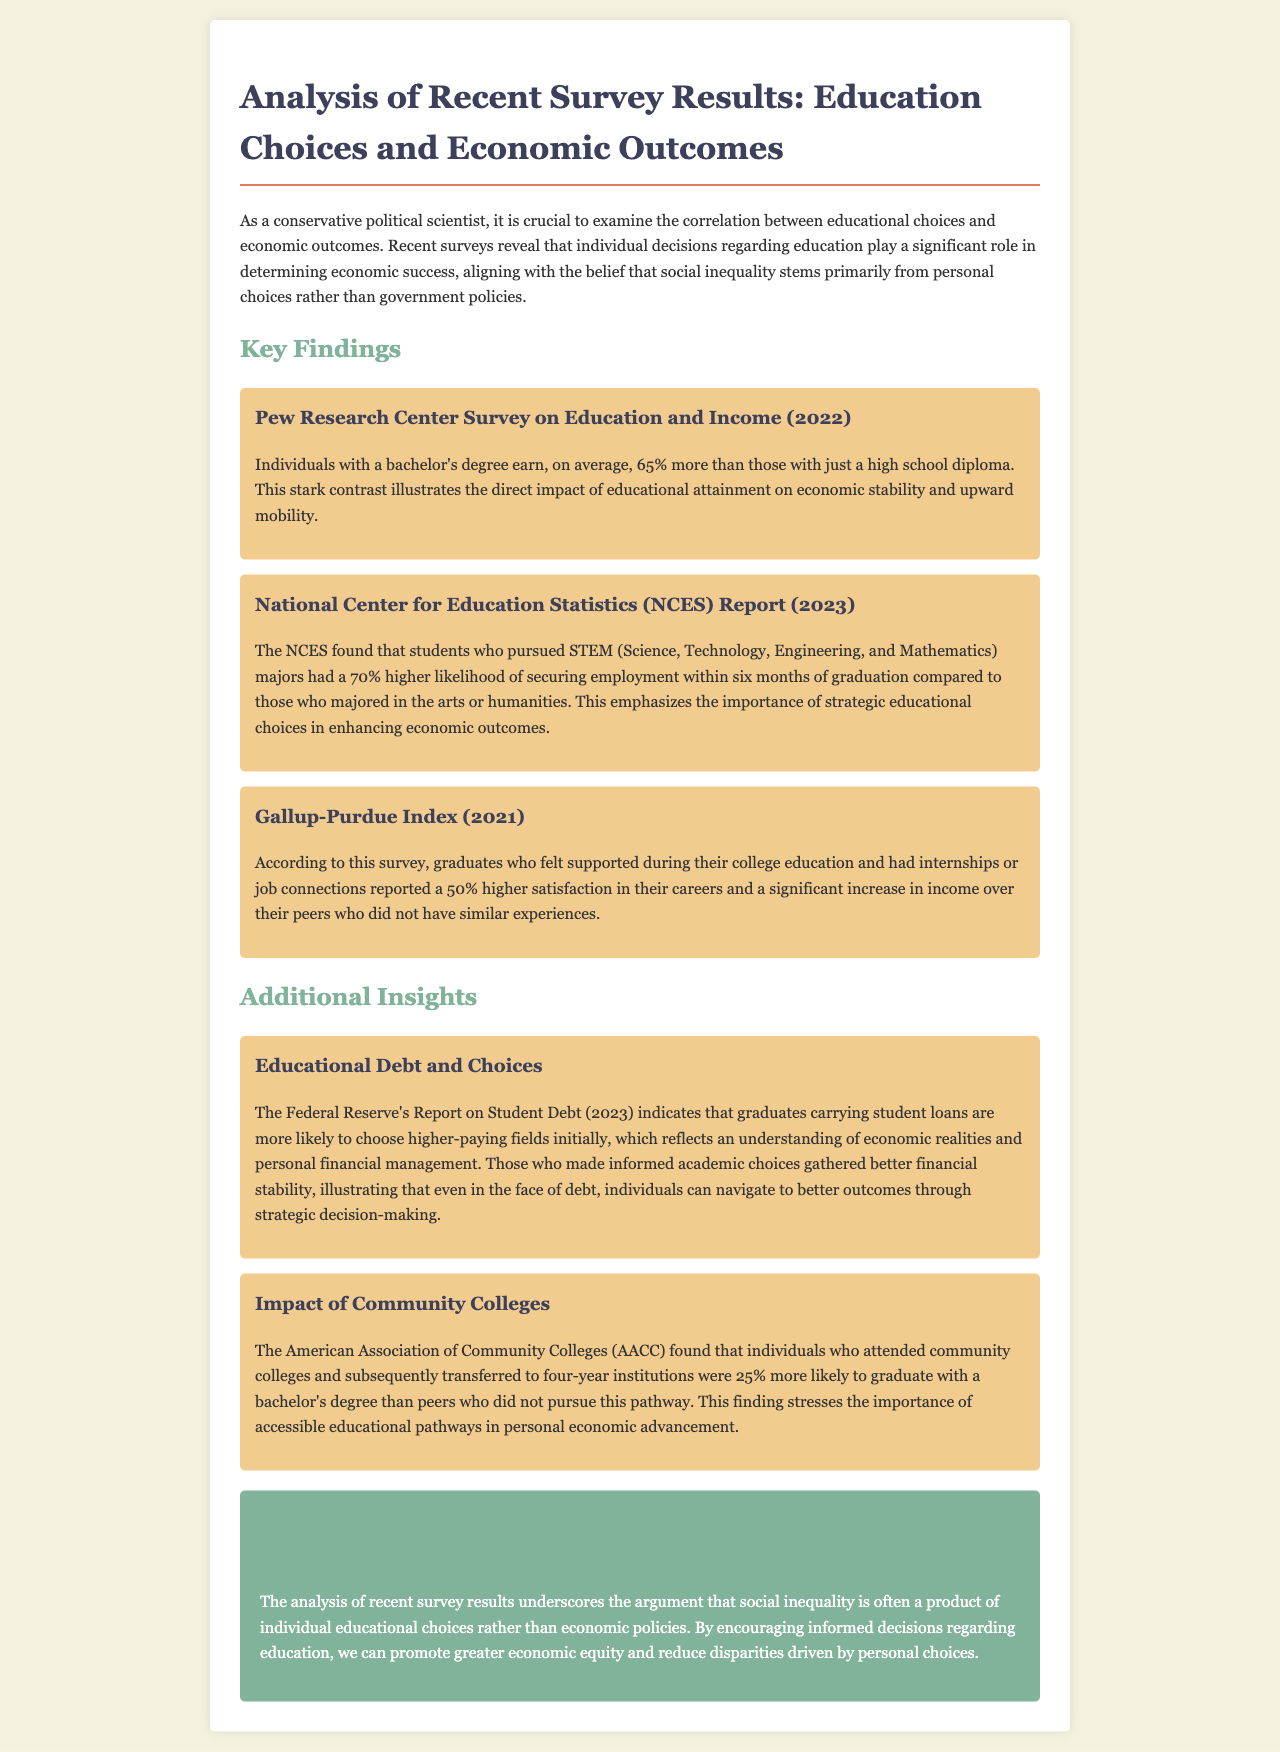What is the average income difference between individuals with a bachelor's degree and those with just a high school diploma? The document states that individuals with a bachelor's degree earn, on average, 65% more than those with just a high school diploma.
Answer: 65% What is the likelihood of STEM major graduates securing employment within six months? According to the NCES report, students who pursued STEM majors had a 70% higher likelihood of securing employment within six months of graduation.
Answer: 70% Which index reported on graduates' satisfaction in their careers? The information comes from the Gallup-Purdue Index.
Answer: Gallup-Purdue Index How much higher is the satisfaction for graduates with support during their college education? The document mentions that graduates who felt supported reported a 50% higher satisfaction in their careers.
Answer: 50% What percentage more likely are community college attendees to graduate with a bachelor's degree? Individuals who attended community colleges and transferred to four-year institutions were 25% more likely to graduate with a bachelor's degree.
Answer: 25% What aspect of education does the document emphasize as a source of social inequality? The analysis suggests that social inequality is often a product of individual educational choices.
Answer: Individual educational choices What does the Federal Reserve's report on student debt indicate about graduates carrying student loans? The report indicates that graduates carrying student loans are more likely to choose higher-paying fields initially.
Answer: Higher-paying fields What is one benefit of pursuing community college before a four-year institution? The document specifies that attending community colleges increases the likelihood of graduating with a bachelor's degree.
Answer: Increases likelihood of graduation 